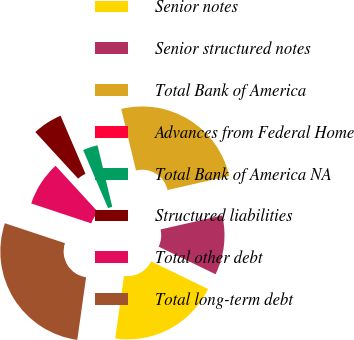Convert chart to OTSL. <chart><loc_0><loc_0><loc_500><loc_500><pie_chart><fcel>Senior notes<fcel>Senior structured notes<fcel>Total Bank of America<fcel>Advances from Federal Home<fcel>Total Bank of America NA<fcel>Structured liabilities<fcel>Total other debt<fcel>Total long-term debt<nl><fcel>20.04%<fcel>10.75%<fcel>25.19%<fcel>0.01%<fcel>2.69%<fcel>5.38%<fcel>8.07%<fcel>27.88%<nl></chart> 